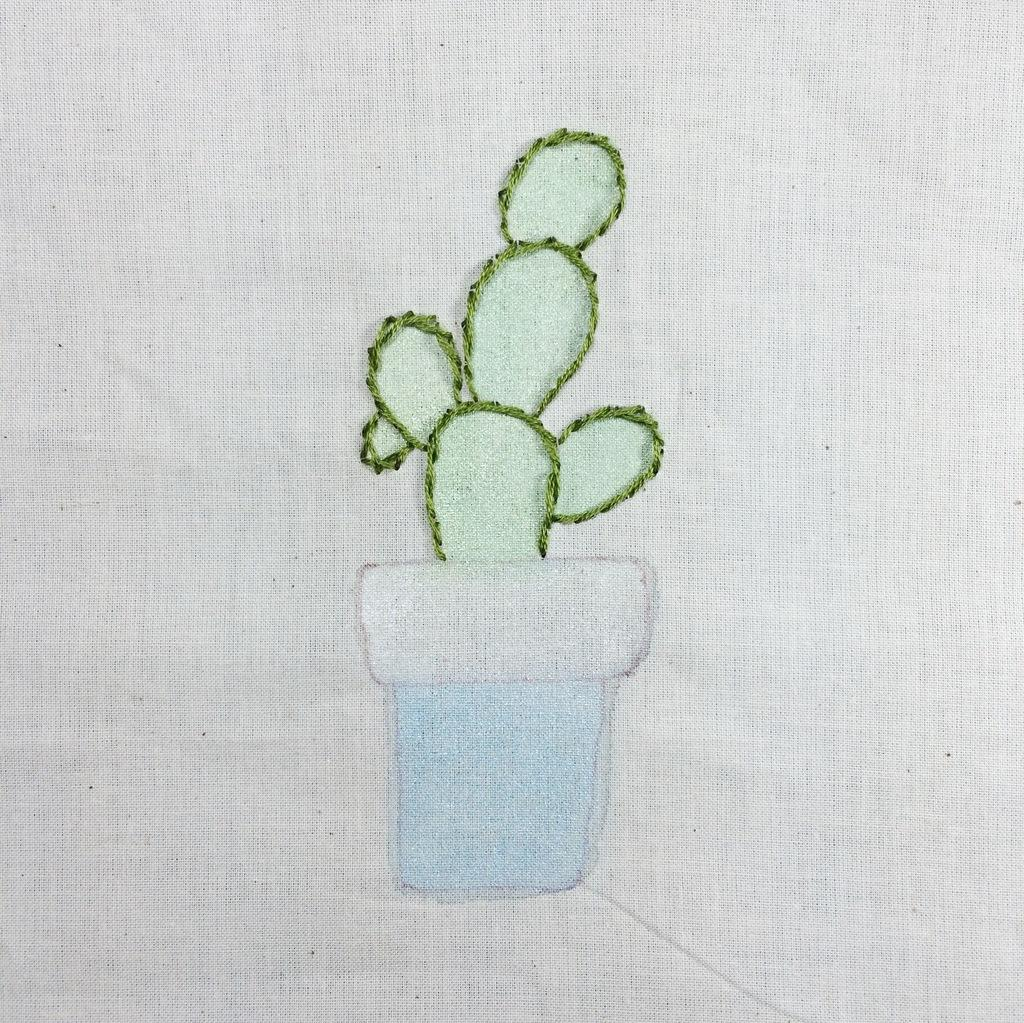What is depicted in the image? There is a diagram of a plant in the image. What is the plant placed in? There is a pot in the image. What is the pot resting on? The pot is placed on a cloth. What type of wheel is used to water the plant in the image? There is no wheel present in the image, and the plant is not being watered. 